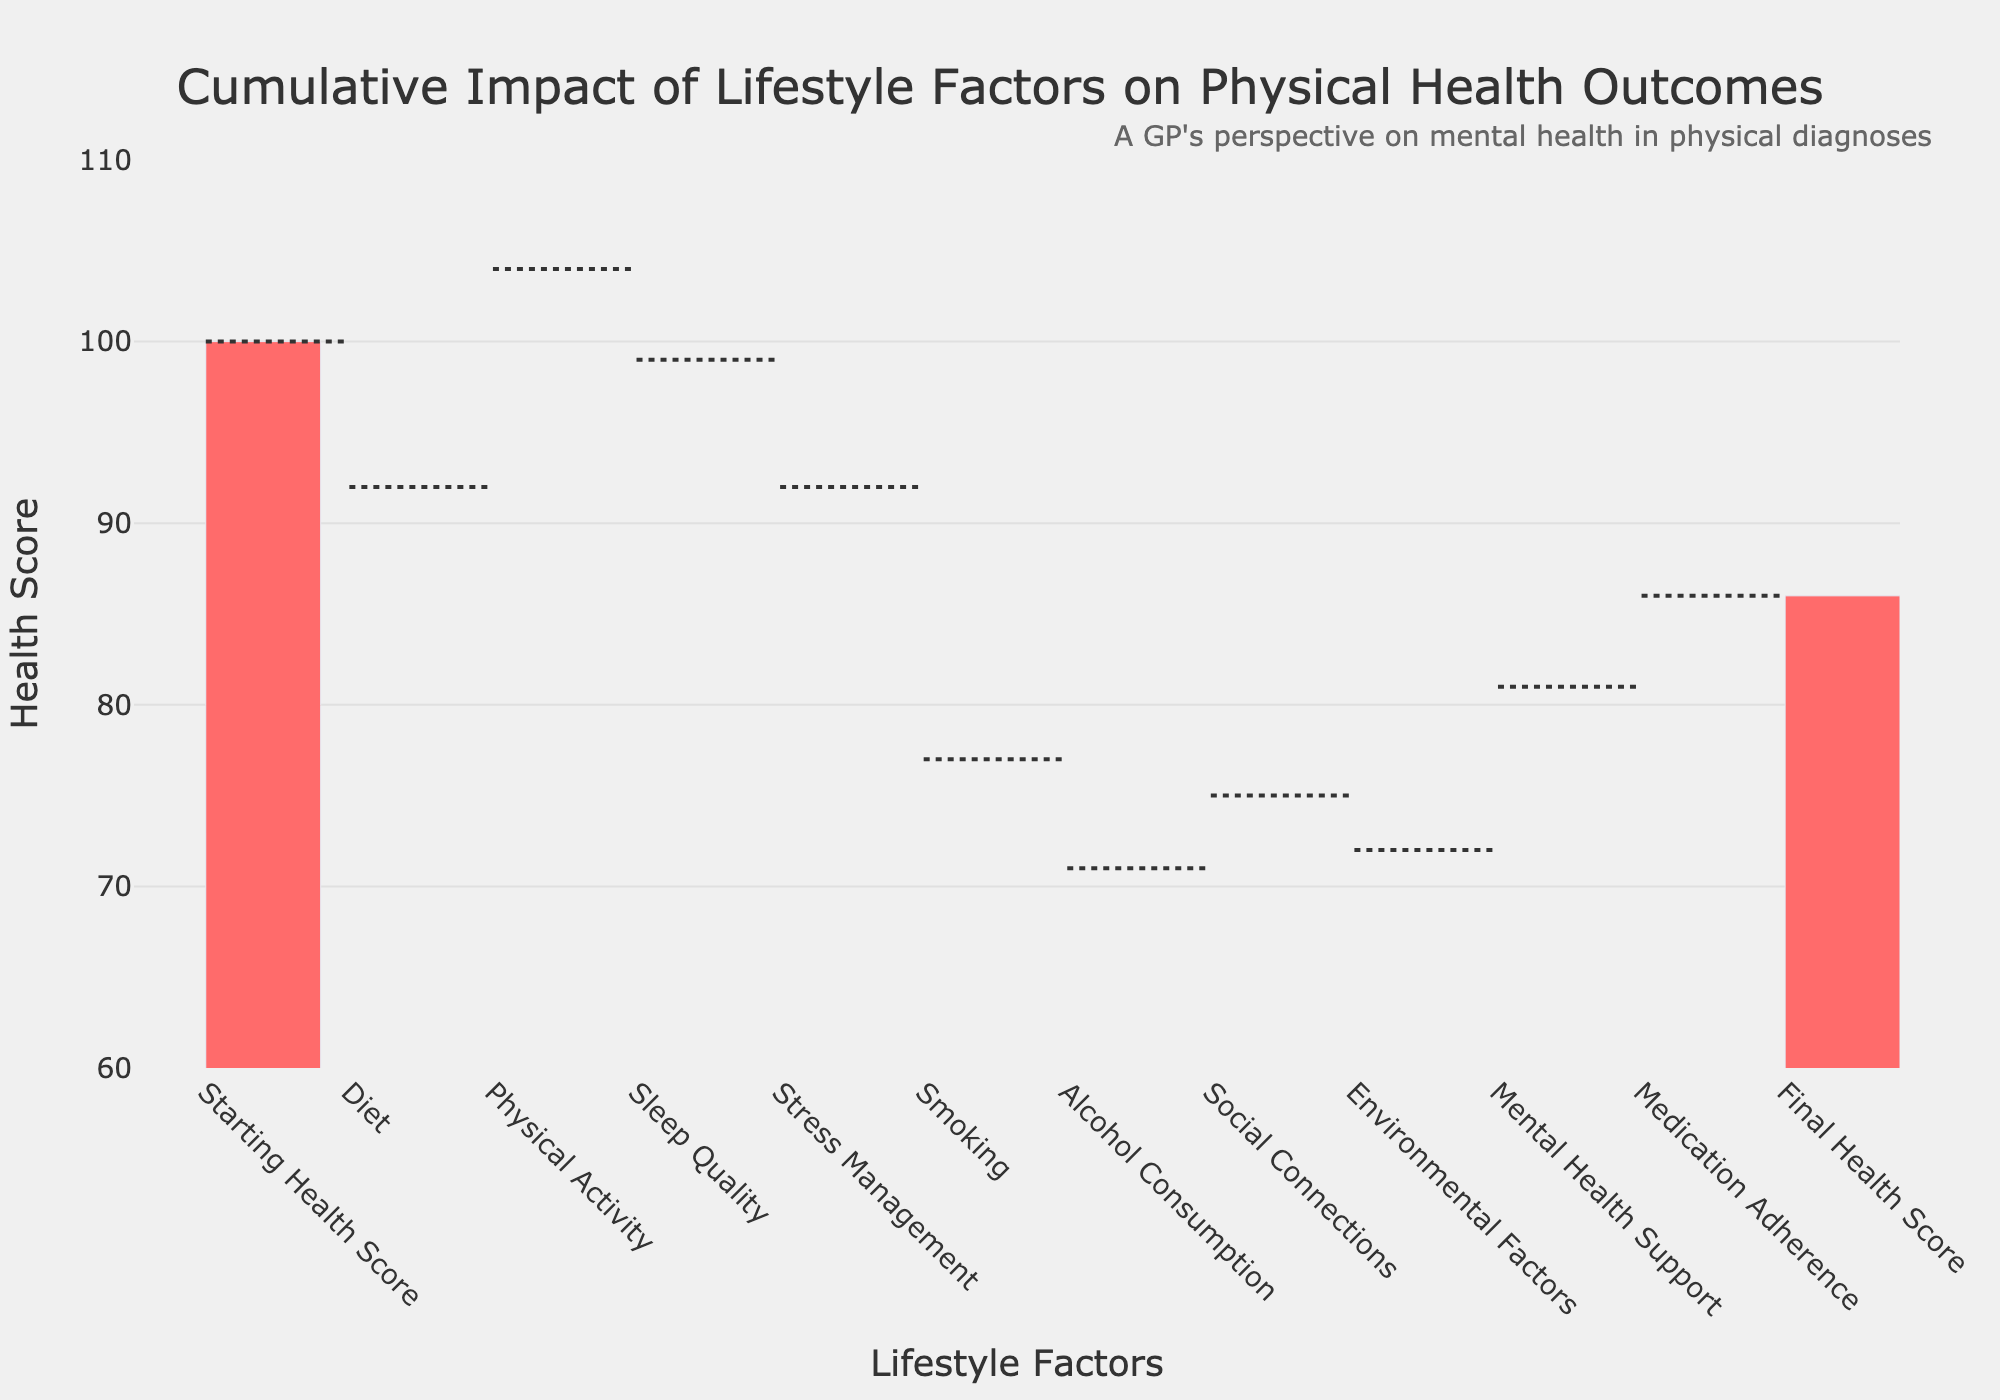What is the title of the figure? The title of the figure can be found at the top of the chart. It is specified to give an overview of the chart’s purpose.
Answer: Cumulative Impact of Lifestyle Factors on Physical Health Outcomes What factor has the most negative impact on the health score? To identify the factor with the most negative impact, look for the bar with the largest decrease.
Answer: Smoking How does the final health score compare to the starting health score? The final health score can be found at the end of the chart, and the starting health score is at the beginning. Compare these two values to see the difference.
Answer: 14 points lower What is the cumulative impact of positive factors on the health score? Add up the impacts of all the factors that have a positive impact, using the respective bars in the chart. The positive factors are Physical Activity, Social Connections, Mental Health Support, and Medication Adherence.
Answer: 30 Which factor has the highest positive impact on the health score? To find this, identify the bar among the positive impacts that shows the highest increase.
Answer: Physical Activity What is the impact of Mental Health Support on the health score? Look for the specific bar labeled Mental Health Support and note the impact it has on the health score.
Answer: +9 How does the impact of Diet compare to the impact of Alcohol Consumption? Compare the bars representing Diet and Alcohol Consumption to determine which has a greater negative impact.
Answer: Diet has a worse impact (-8 compared to -6) What is the cumulative impact of negative factors on the health score? Add up the impacts of all negative factors. These factors are Diet, Sleep Quality, Stress Management, Smoking, Alcohol Consumption, and Environmental Factors.
Answer: -44 Is Social Connections' impact positive or negative? Check the bar labeled Social Connections to determine whether it has a positive or negative impact.
Answer: Positive What is the net change in health score due to all the factors listed? Calculate the final health score by summing up all the impacts listed on the chart, starting from the Starting Health Score.
Answer: -14 